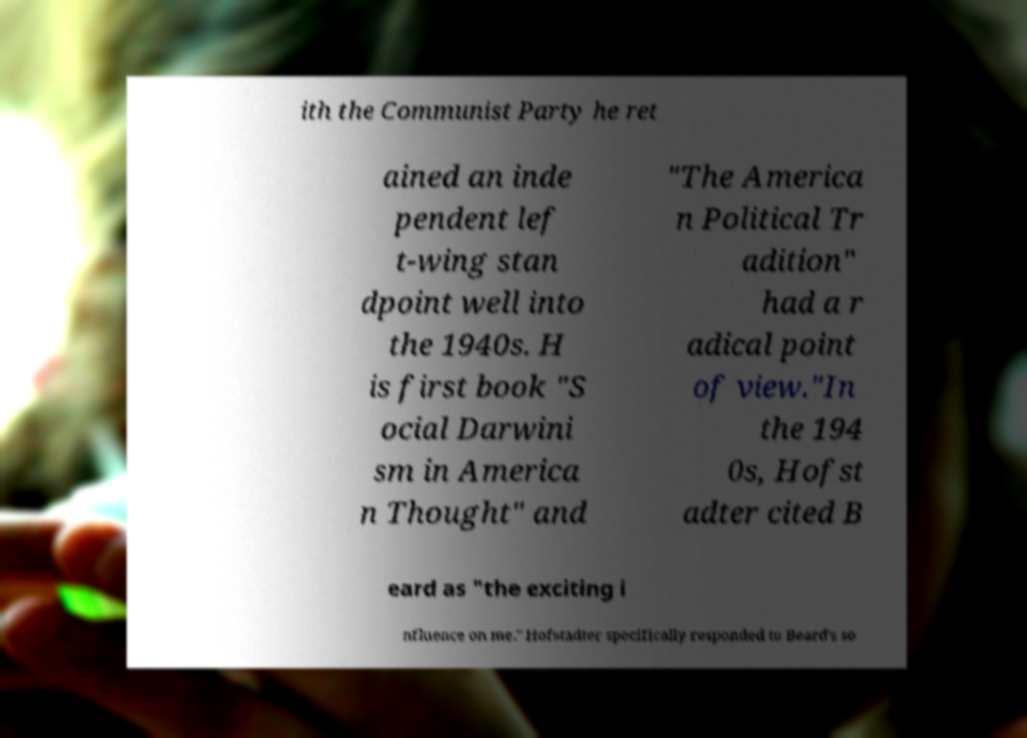Can you accurately transcribe the text from the provided image for me? ith the Communist Party he ret ained an inde pendent lef t-wing stan dpoint well into the 1940s. H is first book "S ocial Darwini sm in America n Thought" and "The America n Political Tr adition" had a r adical point of view."In the 194 0s, Hofst adter cited B eard as "the exciting i nfluence on me." Hofstadter specifically responded to Beard's so 